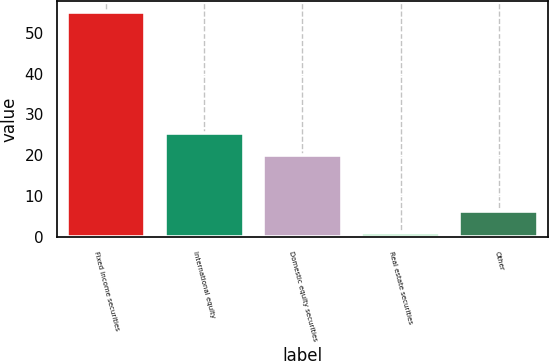Convert chart. <chart><loc_0><loc_0><loc_500><loc_500><bar_chart><fcel>Fixed income securities<fcel>International equity<fcel>Domestic equity securities<fcel>Real estate securities<fcel>Other<nl><fcel>55<fcel>25.4<fcel>20<fcel>1<fcel>6.4<nl></chart> 